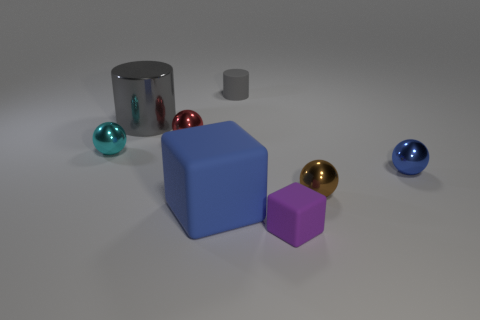There is a blue ball; is its size the same as the cylinder on the left side of the large blue matte object?
Give a very brief answer. No. What is the color of the rubber cylinder?
Offer a terse response. Gray. What shape is the blue thing that is to the left of the cylinder on the right side of the blue thing on the left side of the purple block?
Your answer should be compact. Cube. There is a blue thing that is in front of the small metal sphere right of the brown shiny object; what is its material?
Offer a terse response. Rubber. The large blue object that is the same material as the purple object is what shape?
Provide a short and direct response. Cube. What number of tiny blue metallic things are in front of the large shiny thing?
Provide a short and direct response. 1. Are there any cyan rubber cubes?
Make the answer very short. No. What is the color of the small shiny sphere that is behind the shiny object to the left of the gray thing left of the small red metal sphere?
Your answer should be very brief. Red. There is a tiny metal object that is behind the small cyan sphere; is there a red metal object in front of it?
Your response must be concise. No. Is the color of the matte thing that is behind the blue matte thing the same as the big object behind the brown metal ball?
Keep it short and to the point. Yes. 